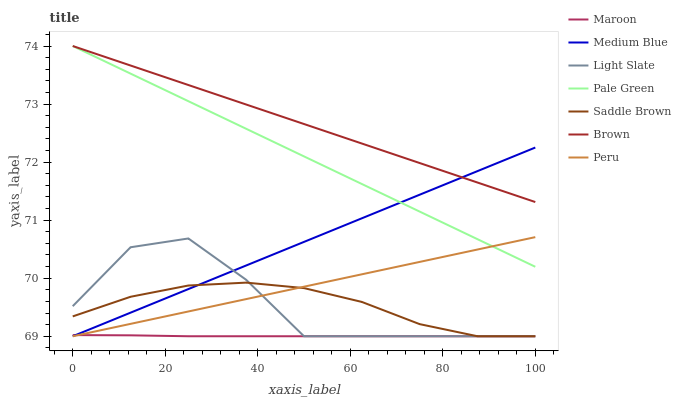Does Maroon have the minimum area under the curve?
Answer yes or no. Yes. Does Brown have the maximum area under the curve?
Answer yes or no. Yes. Does Light Slate have the minimum area under the curve?
Answer yes or no. No. Does Light Slate have the maximum area under the curve?
Answer yes or no. No. Is Medium Blue the smoothest?
Answer yes or no. Yes. Is Light Slate the roughest?
Answer yes or no. Yes. Is Light Slate the smoothest?
Answer yes or no. No. Is Medium Blue the roughest?
Answer yes or no. No. Does Pale Green have the lowest value?
Answer yes or no. No. Does Light Slate have the highest value?
Answer yes or no. No. Is Peru less than Brown?
Answer yes or no. Yes. Is Brown greater than Maroon?
Answer yes or no. Yes. Does Peru intersect Brown?
Answer yes or no. No. 